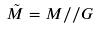Convert formula to latex. <formula><loc_0><loc_0><loc_500><loc_500>\tilde { M } = M / / G</formula> 